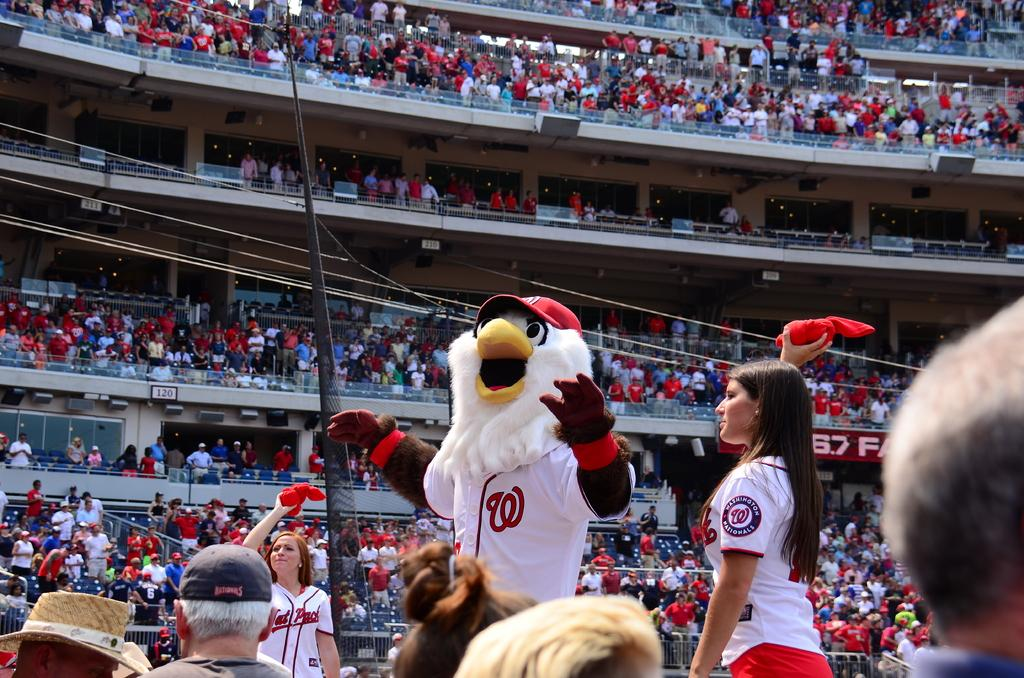<image>
Summarize the visual content of the image. Women wearing Washington Nationals badges throwing t-shirts to lucky fans. 